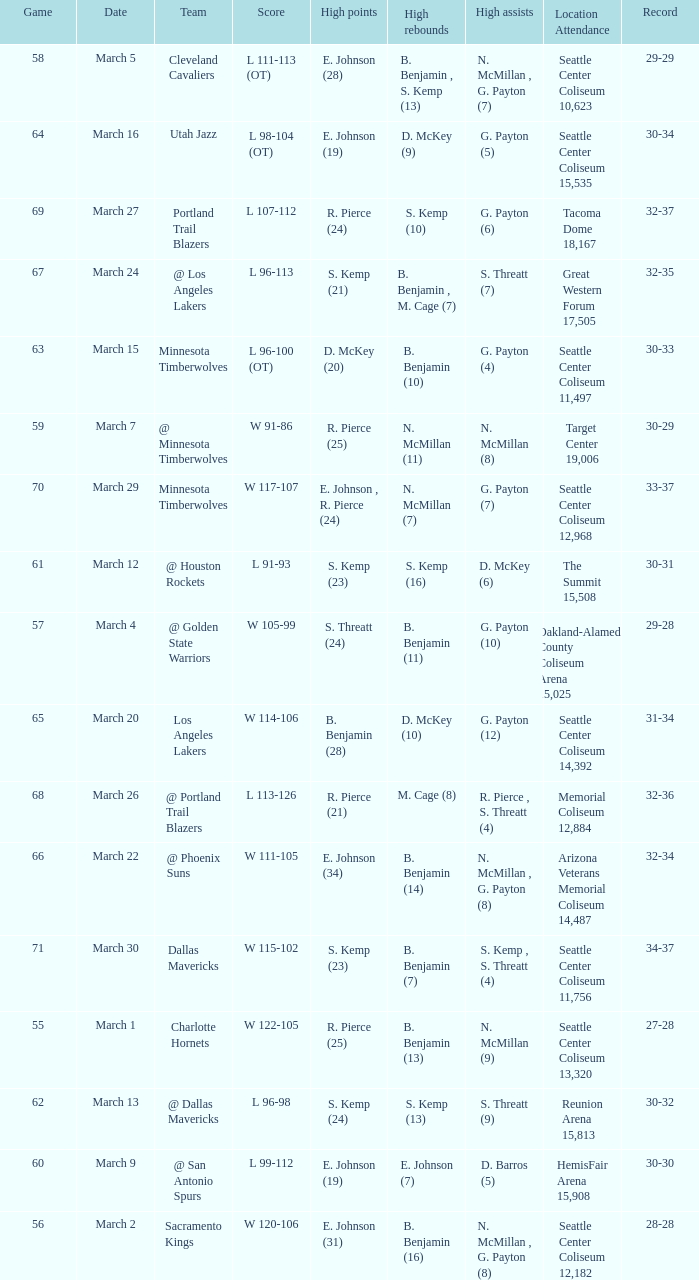WhichScore has a Location Attendance of seattle center coliseum 11,497? L 96-100 (OT). 